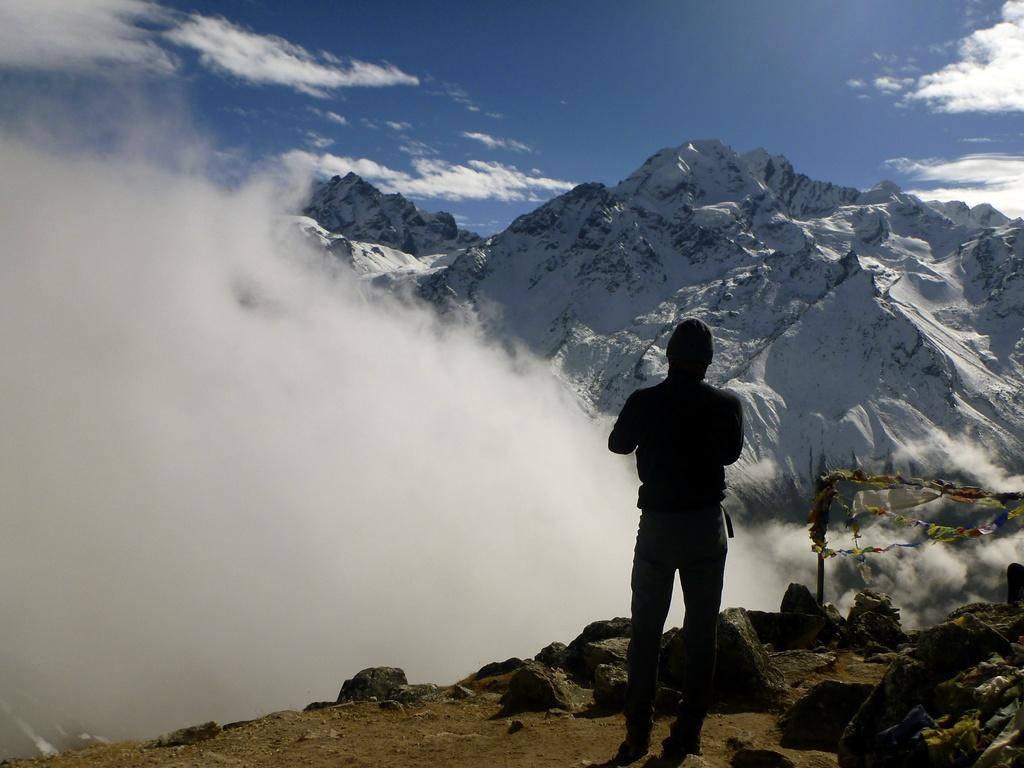Who or what is present in the image? There is a person in the image. What type of natural features can be seen in the image? There are stones and mountains in the image. What is the weather like in the image? There is fog in the image, which suggests a cool or damp environment. What is visible in the background of the image? The sky is visible in the background of the image. What month is it in the image? The month cannot be determined from the image, as there is no information about the time of year. How does the person's digestion appear to be affected by the environment in the image? There is no information about the person's digestion in the image, so it cannot be determined. 